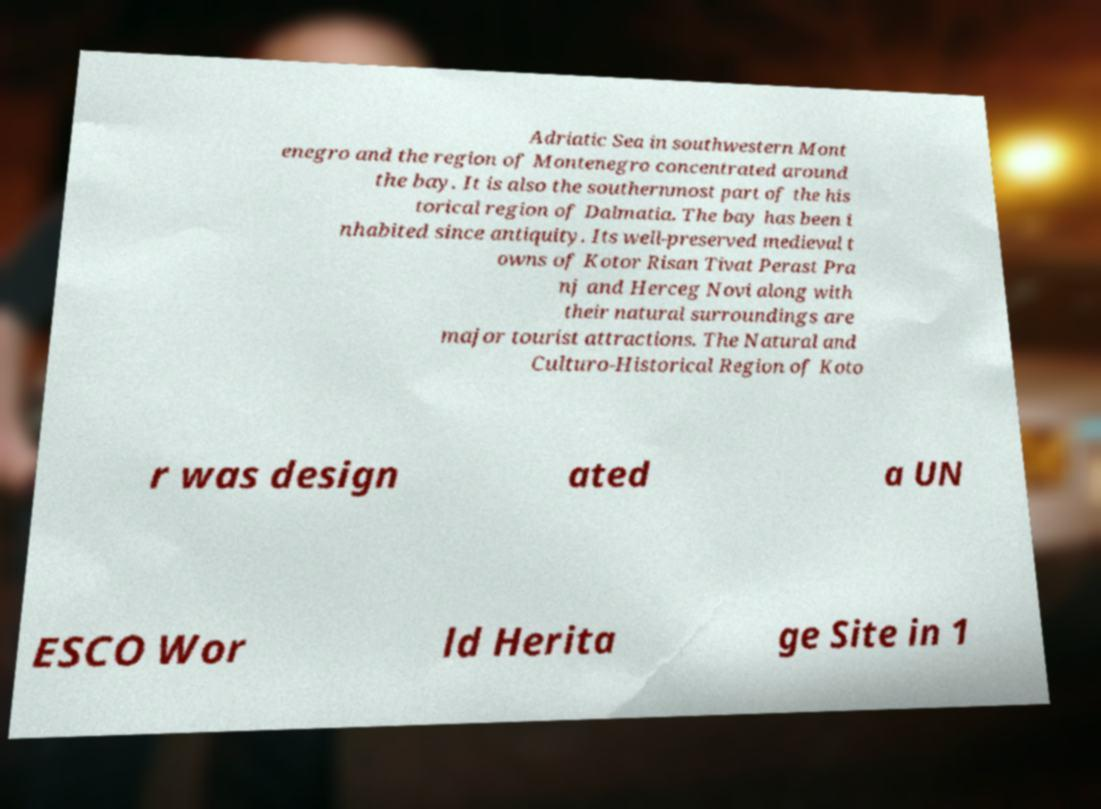I need the written content from this picture converted into text. Can you do that? Adriatic Sea in southwestern Mont enegro and the region of Montenegro concentrated around the bay. It is also the southernmost part of the his torical region of Dalmatia. The bay has been i nhabited since antiquity. Its well-preserved medieval t owns of Kotor Risan Tivat Perast Pra nj and Herceg Novi along with their natural surroundings are major tourist attractions. The Natural and Culturo-Historical Region of Koto r was design ated a UN ESCO Wor ld Herita ge Site in 1 